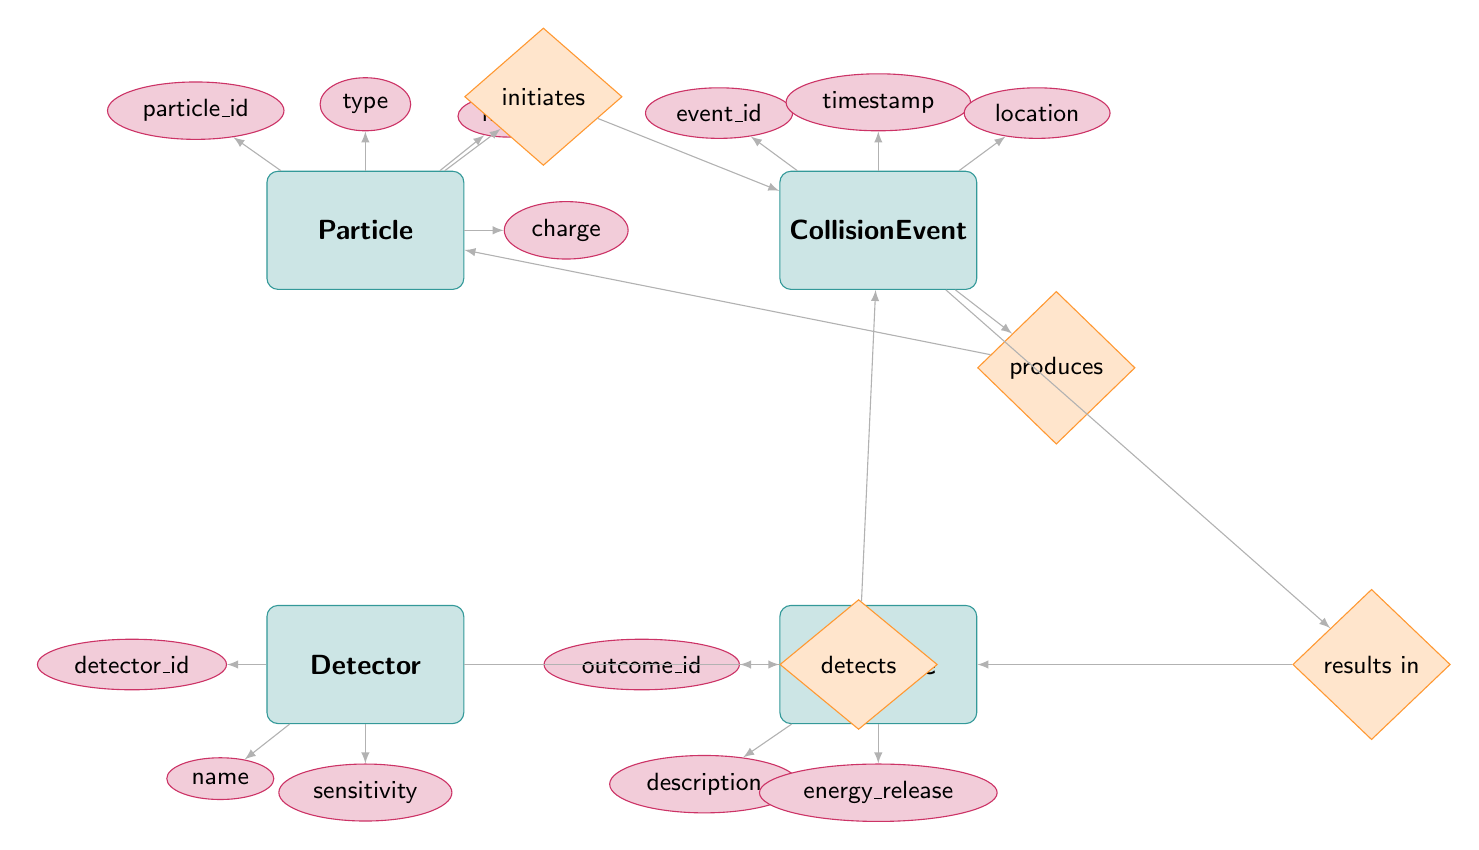What entity has the primary key 'particle_id'? The primary key 'particle_id' is listed under the 'Particle' entity in the diagram.
Answer: Particle How many attributes are associated with the 'Outcome' entity? The 'Outcome' entity has three attributes: 'outcome_id', 'description', and 'energy_release'. Counting these, we find a total of three attributes.
Answer: 3 What is the relationship between 'CollisionEvent' and 'Outcome'? The diagram indicates that 'CollisionEvent' has a relationship with 'Outcome' labeled 'results_in'. This means that outcomes are resultant events from collisions.
Answer: results in What is the type of the entity 'Detector'? The entity 'Detector' is a basic entity in this diagram, described by various attributes but not as having a subtype, thus the direct answer pertains to it simply being a 'Detector'.
Answer: Detector Which entity initiates a CollisionEvent? The diagram shows that a 'Particle' initiates a 'CollisionEvent', evident from the relationship labeled 'initiates' connecting 'Particle' to 'CollisionEvent'.
Answer: Particle What is the common attribute for 'Particle' and 'CollisionEvent'? Both entities have unique attributes that do not overlap; hence there is no common attribute. The question seeks clarification that attributes are specific to their respective entities.
Answer: None How many total entities are represented in the diagram? The diagram includes four entities: 'Particle', 'CollisionEvent', 'Detector', and 'Outcome'. Counting all four gives us the total entities represented.
Answer: 4 What does the 'produces' relationship indicate? The 'produces' relationship in the diagram connects 'CollisionEvent' and 'Particle', indicating that a collision event leads to the production of new particles.
Answer: produces What is the primary key of the 'Detector' entity? The primary key for 'Detector' is specified as 'detector_id' in the attributes list under the entity.
Answer: detector_id 